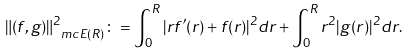<formula> <loc_0><loc_0><loc_500><loc_500>\| ( f , g ) \| _ { \ m c E ( R ) } ^ { 2 } \colon = \int _ { 0 } ^ { R } | r f ^ { \prime } ( r ) + f ( r ) | ^ { 2 } d r + \int _ { 0 } ^ { R } r ^ { 2 } | g ( r ) | ^ { 2 } d r .</formula> 